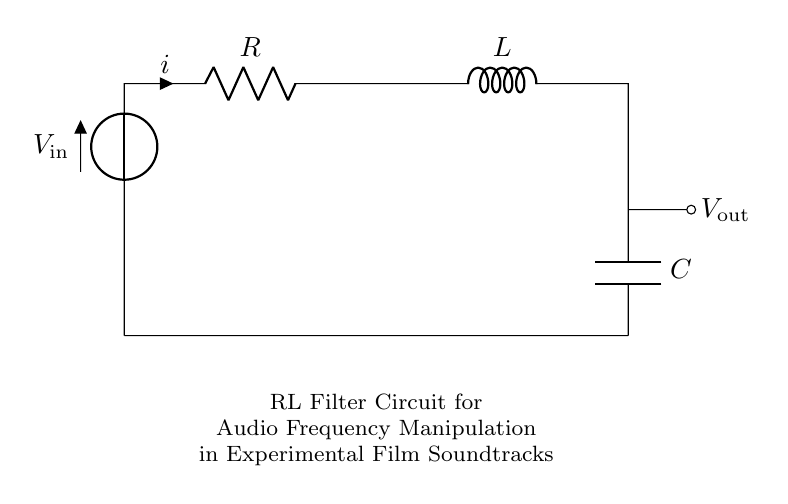What components are in this circuit? The circuit consists of a resistor, inductor, and capacitor. These components are fundamental to the function of the RL filter circuit.
Answer: Resistor, Inductor, Capacitor What is the input voltage labeled in this diagram? The input voltage is indicated as V in the circuit. It is positioned at the beginning of the circuit, providing the necessary power for the components.
Answer: V What is the output voltage in the circuit? The output voltage is labeled V out, and it can be found at the point where the load is connected, after the inductor and capacitor.
Answer: V out What is the purpose of the inductor in this circuit? The inductor functions to impede changes in current, which is vital for filtering out unwanted frequencies, thus affecting the audio signal passed through.
Answer: Filtering How does changing the resistance value affect the circuit's functionality? Altering resistance changes the filter's cutoff frequency; a higher resistance typically leads to a lower cutoff frequency, thus manipulating audio characteristics.
Answer: Changes cutoff frequency How does the combination of the resistor and inductor influence audio signal modulation? The resistance and inductance together create a phase shift and modify the frequency response of the circuit, which is critical in achieving specific audio effects in film soundtracks.
Answer: Modifies frequency response 